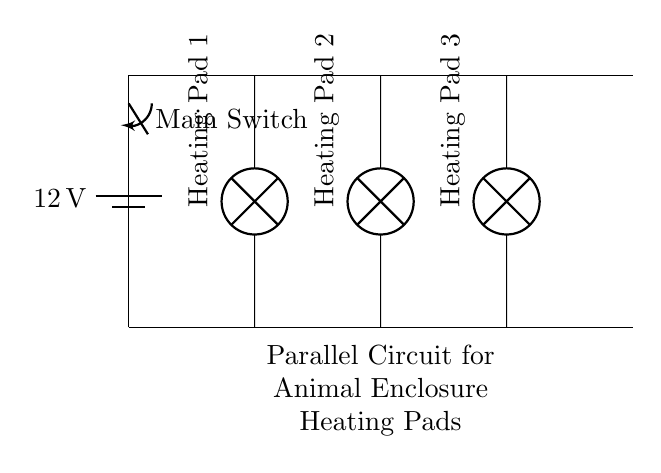What is the voltage supplied by the battery? The voltage is clearly marked on the battery in the circuit. It indicates a potential difference of 12 volts across the power source.
Answer: 12 volts How many heating pads are connected in the circuit? By counting the lamps in the circuit diagram, there are three distinct heating pad components labeled as Heating Pad 1, Heating Pad 2, and Heating Pad 3.
Answer: Three What is the role of the switch in this circuit? The switch serves as a means to control the flow of electricity to the entire circuit. If the switch is open, no current flows to the heating pads. If it is closed, current can flow to the heating pads.
Answer: Control flow What happens to the voltage across each heating pad? In a parallel circuit, each component has the same voltage across it, equal to the source voltage. Therefore, each heating pad receives the full 12 volts provided by the battery.
Answer: 12 volts each If one heating pad fails, what happens to the others? In a parallel circuit, if one component fails (like one heating pad), the others continue to operate normally because they are connected independently to the same voltage source.
Answer: Others remain operational What type of circuit is represented here? The circuit is identified as a parallel circuit due to the arrangement of the heating pads connected across the same voltage source, allowing multiple paths for current to flow.
Answer: Parallel circuit 